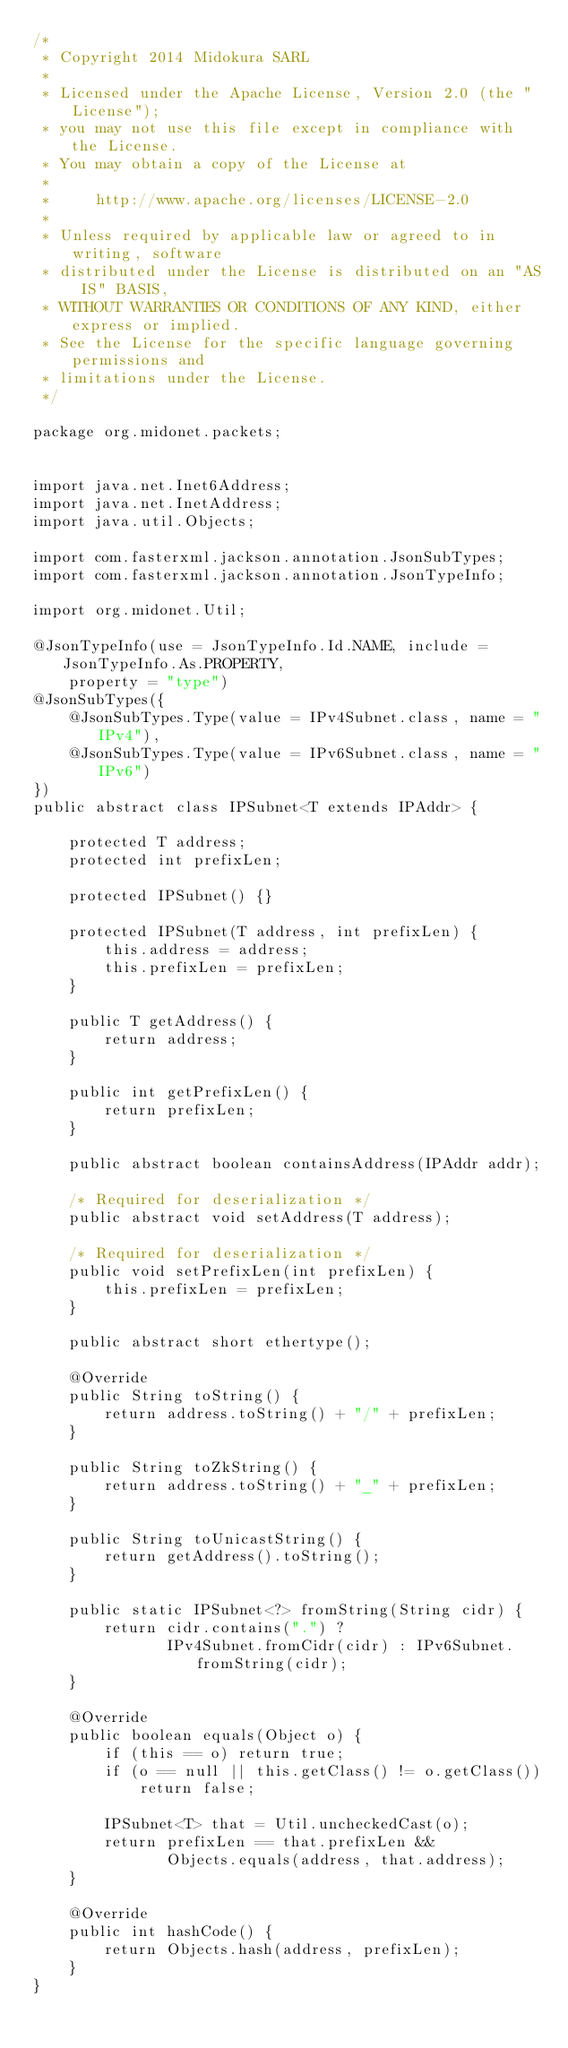<code> <loc_0><loc_0><loc_500><loc_500><_Java_>/*
 * Copyright 2014 Midokura SARL
 *
 * Licensed under the Apache License, Version 2.0 (the "License");
 * you may not use this file except in compliance with the License.
 * You may obtain a copy of the License at
 *
 *     http://www.apache.org/licenses/LICENSE-2.0
 *
 * Unless required by applicable law or agreed to in writing, software
 * distributed under the License is distributed on an "AS IS" BASIS,
 * WITHOUT WARRANTIES OR CONDITIONS OF ANY KIND, either express or implied.
 * See the License for the specific language governing permissions and
 * limitations under the License.
 */

package org.midonet.packets;


import java.net.Inet6Address;
import java.net.InetAddress;
import java.util.Objects;

import com.fasterxml.jackson.annotation.JsonSubTypes;
import com.fasterxml.jackson.annotation.JsonTypeInfo;

import org.midonet.Util;

@JsonTypeInfo(use = JsonTypeInfo.Id.NAME, include = JsonTypeInfo.As.PROPERTY,
    property = "type")
@JsonSubTypes({
    @JsonSubTypes.Type(value = IPv4Subnet.class, name = "IPv4"),
    @JsonSubTypes.Type(value = IPv6Subnet.class, name = "IPv6")
})
public abstract class IPSubnet<T extends IPAddr> {

    protected T address;
    protected int prefixLen;

    protected IPSubnet() {}

    protected IPSubnet(T address, int prefixLen) {
        this.address = address;
        this.prefixLen = prefixLen;
    }

    public T getAddress() {
        return address;
    }

    public int getPrefixLen() {
        return prefixLen;
    }

    public abstract boolean containsAddress(IPAddr addr);

    /* Required for deserialization */
    public abstract void setAddress(T address);

    /* Required for deserialization */
    public void setPrefixLen(int prefixLen) {
        this.prefixLen = prefixLen;
    }

    public abstract short ethertype();

    @Override
    public String toString() {
        return address.toString() + "/" + prefixLen;
    }

    public String toZkString() {
        return address.toString() + "_" + prefixLen;
    }

    public String toUnicastString() {
        return getAddress().toString();
    }

    public static IPSubnet<?> fromString(String cidr) {
        return cidr.contains(".") ?
               IPv4Subnet.fromCidr(cidr) : IPv6Subnet.fromString(cidr);
    }

    @Override
    public boolean equals(Object o) {
        if (this == o) return true;
        if (o == null || this.getClass() != o.getClass())
            return false;

        IPSubnet<T> that = Util.uncheckedCast(o);
        return prefixLen == that.prefixLen &&
               Objects.equals(address, that.address);
    }

    @Override
    public int hashCode() {
        return Objects.hash(address, prefixLen);
    }
}
</code> 